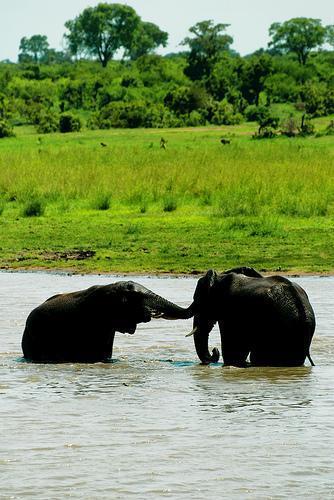How many elephants are there?
Give a very brief answer. 2. 